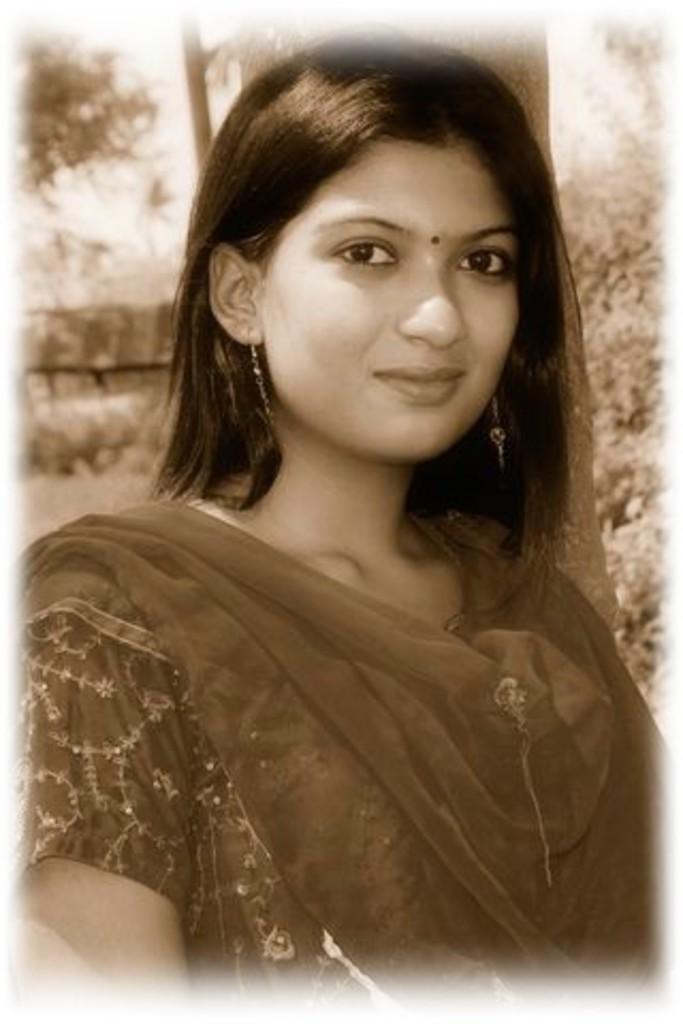In one or two sentences, can you explain what this image depicts? This is a black and white picture and in this picture we can see a woman smiling and in the background we can see trees. 